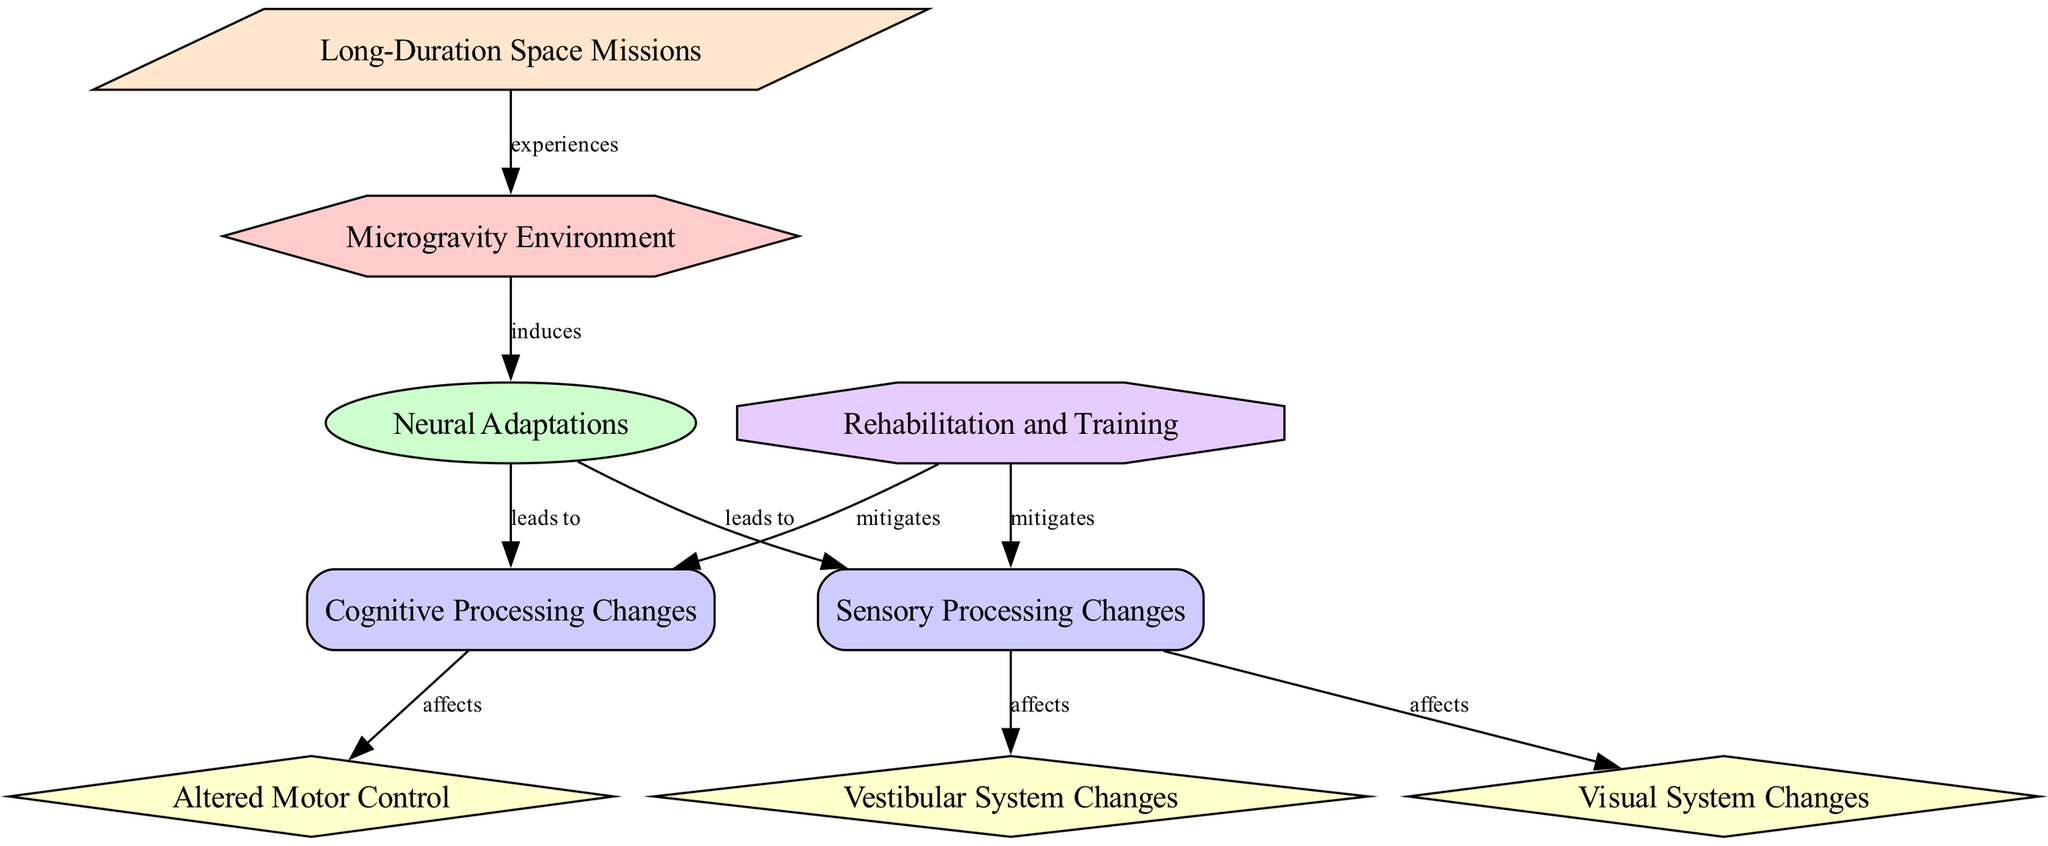What is the initial condition in the diagram? The initial condition is represented by the first node labeled "Microgravity Environment." This node is the starting point from which all other processes and outcomes flow.
Answer: Microgravity Environment How many outcomes are represented in the diagram? The outcomes in the diagram are "Cognitive Processing Changes" and "Sensory Processing Changes." Counting these nodes shows that there are a total of two outcomes connected to "Neural Adaptations."
Answer: 2 What does "Neural Adaptations" lead to? "Neural Adaptations" leads to two different outcomes: "Cognitive Processing Changes" and "Sensory Processing Changes." Each of these outcomes is connected by edges that illustrate their relationship to the adaptations induced by microgravity.
Answer: Cognitive Processing Changes, Sensory Processing Changes Which system is affected by sensory processing changes? The systems affected by "Sensory Processing Changes" are the "Visual System" and "Vestibular System." This is shown by the edges from "Sensory Processing Changes" pointing to both systems in the diagram.
Answer: Visual System, Vestibular System How does rehabilitation training influence cognitive processing changes? According to the diagram, "Rehabilitation and Training" mitigates the effects of "Cognitive Processing Changes." This means that through rehabilitation training, negative outcomes in cognitive processing can be reduced or prevented.
Answer: Mitigates What scenario experiences a microgravity environment? The "Long-Duration Space Missions" scenario experiences the "Microgravity Environment." The connection is shown in the diagram with an edge pointing from "Long-Duration Space Missions" to "Microgravity Environment."
Answer: Long-Duration Space Missions Which type of adaptation leads to altered motor control? "Cognitive Processing Changes" leads to "Altered Motor Control." The relationship is depicted by an edge indicating that changes in cognitive processing are directly influencing motor control.
Answer: Cognitive Processing Changes What type of adaptation has effects on both visual and vestibular systems? "Sensory Processing Changes" affects both "Visual System Changes" and "Vestibular System Changes." The connections indicating these effects are shown by edges extending from "Sensory Processing Changes" to each respective system.
Answer: Sensory Processing Changes What effect does sensory processing changes have on the visual system? The diagram indicates that "Sensory Processing Changes" directly affects the "Visual System Changes." This is evidenced by the edge that connects these two nodes in the diagram.
Answer: Affects 